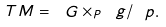Convert formula to latex. <formula><loc_0><loc_0><loc_500><loc_500>T M = \ G \times _ { P } \ g / \ p .</formula> 